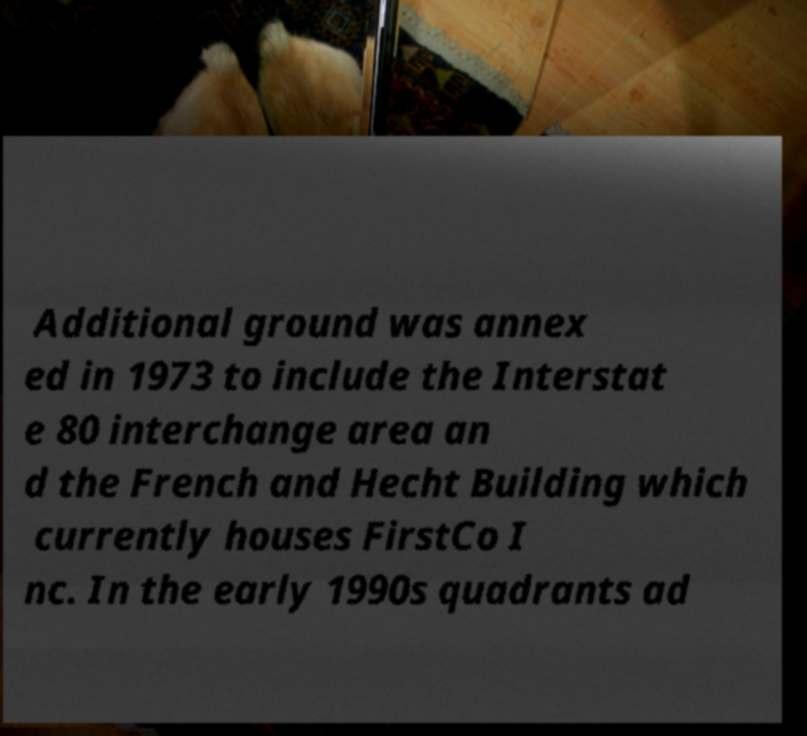I need the written content from this picture converted into text. Can you do that? Additional ground was annex ed in 1973 to include the Interstat e 80 interchange area an d the French and Hecht Building which currently houses FirstCo I nc. In the early 1990s quadrants ad 